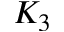Convert formula to latex. <formula><loc_0><loc_0><loc_500><loc_500>K _ { 3 }</formula> 